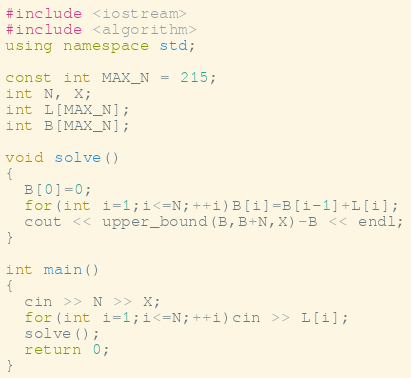<code> <loc_0><loc_0><loc_500><loc_500><_C++_>#include <iostream>
#include <algorithm>
using namespace std;

const int MAX_N = 215;
int N, X;
int L[MAX_N];
int B[MAX_N];

void solve()
{
  B[0]=0;
  for(int i=1;i<=N;++i)B[i]=B[i-1]+L[i];
  cout << upper_bound(B,B+N,X)-B << endl;
}

int main()
{
  cin >> N >> X;
  for(int i=1;i<=N;++i)cin >> L[i];
  solve();
  return 0;
}</code> 